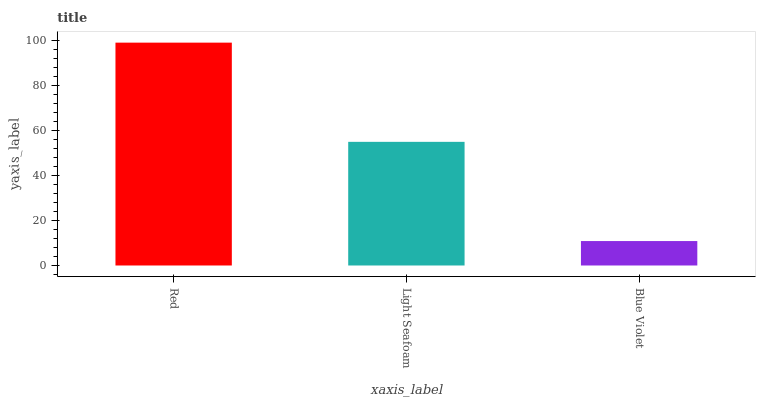Is Blue Violet the minimum?
Answer yes or no. Yes. Is Red the maximum?
Answer yes or no. Yes. Is Light Seafoam the minimum?
Answer yes or no. No. Is Light Seafoam the maximum?
Answer yes or no. No. Is Red greater than Light Seafoam?
Answer yes or no. Yes. Is Light Seafoam less than Red?
Answer yes or no. Yes. Is Light Seafoam greater than Red?
Answer yes or no. No. Is Red less than Light Seafoam?
Answer yes or no. No. Is Light Seafoam the high median?
Answer yes or no. Yes. Is Light Seafoam the low median?
Answer yes or no. Yes. Is Red the high median?
Answer yes or no. No. Is Red the low median?
Answer yes or no. No. 